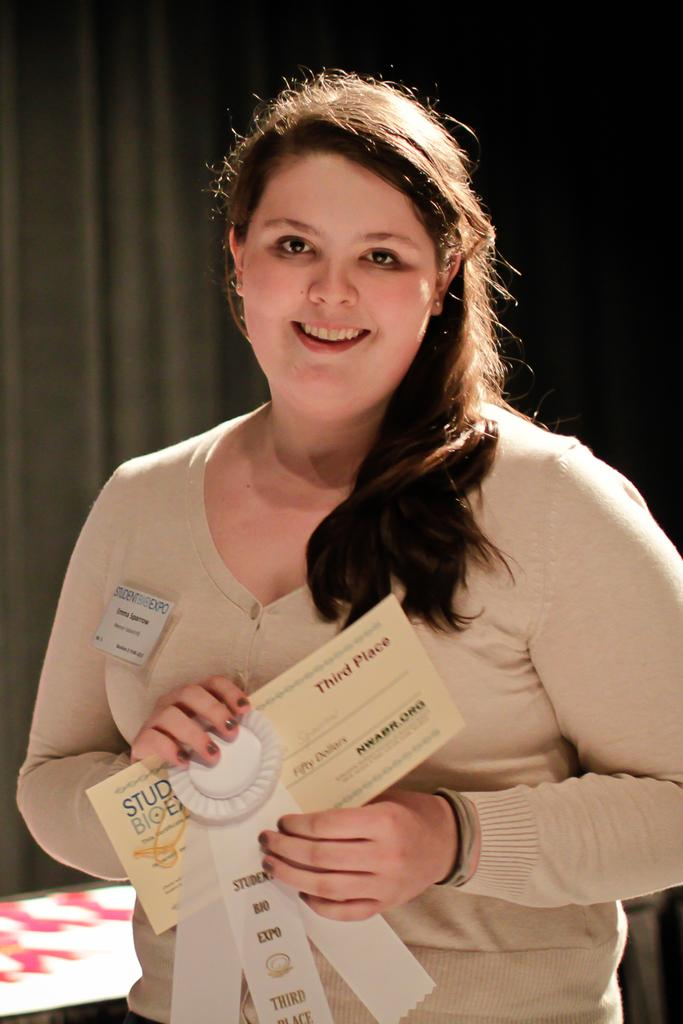What can be seen in the image? There is a person in the image. What is the person wearing? The person is wearing a cream-colored sweatshirt. What is the person holding in their hands? The person is holding a certificate in their hands. What color is the sheet in the background of the image? There is a black-colored sheet in the background of the image. What type of engine can be seen in the image? There is no engine present in the image. Is the person wearing a scarf in the image? The provided facts do not mention a scarf, so we cannot determine if the person is wearing one. 